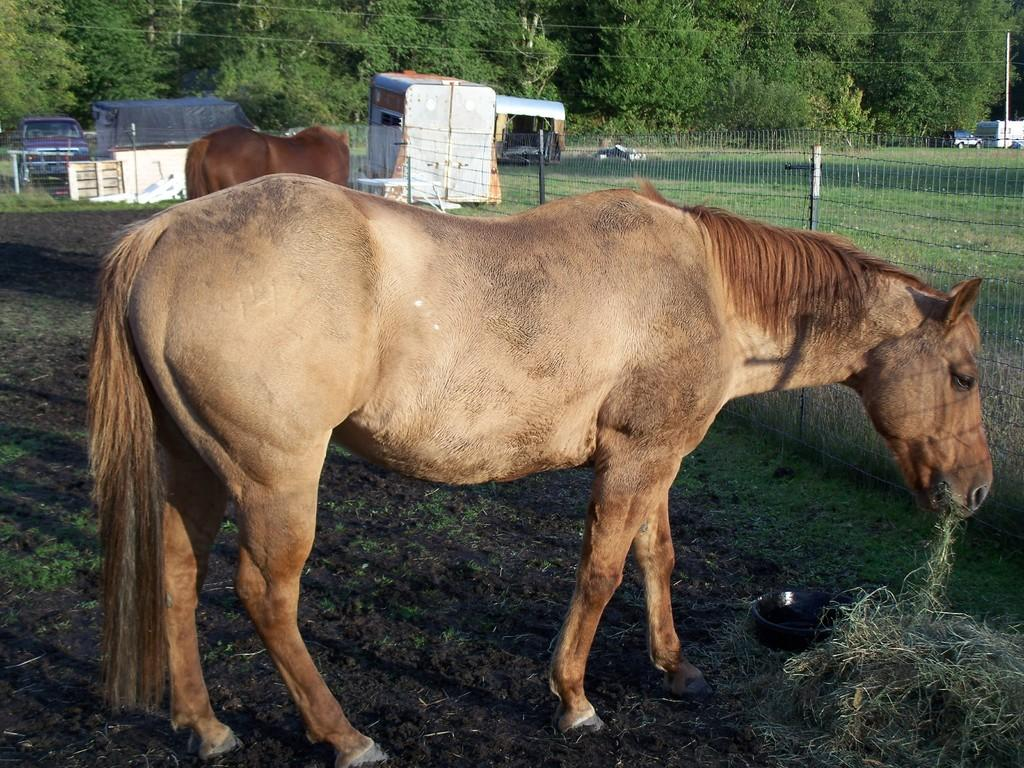What animals can be seen in the image? There are horses in the image. What is in front of the horses? There is a fence in front of the horses. What can be seen in the background of the image? There are vehicles, trees, and cables in the background of the image. What type of legal advice is the lawyer providing on the hill in the image? There is no lawyer or hill present in the image; it features horses with a fence in front of them and various elements in the background. 